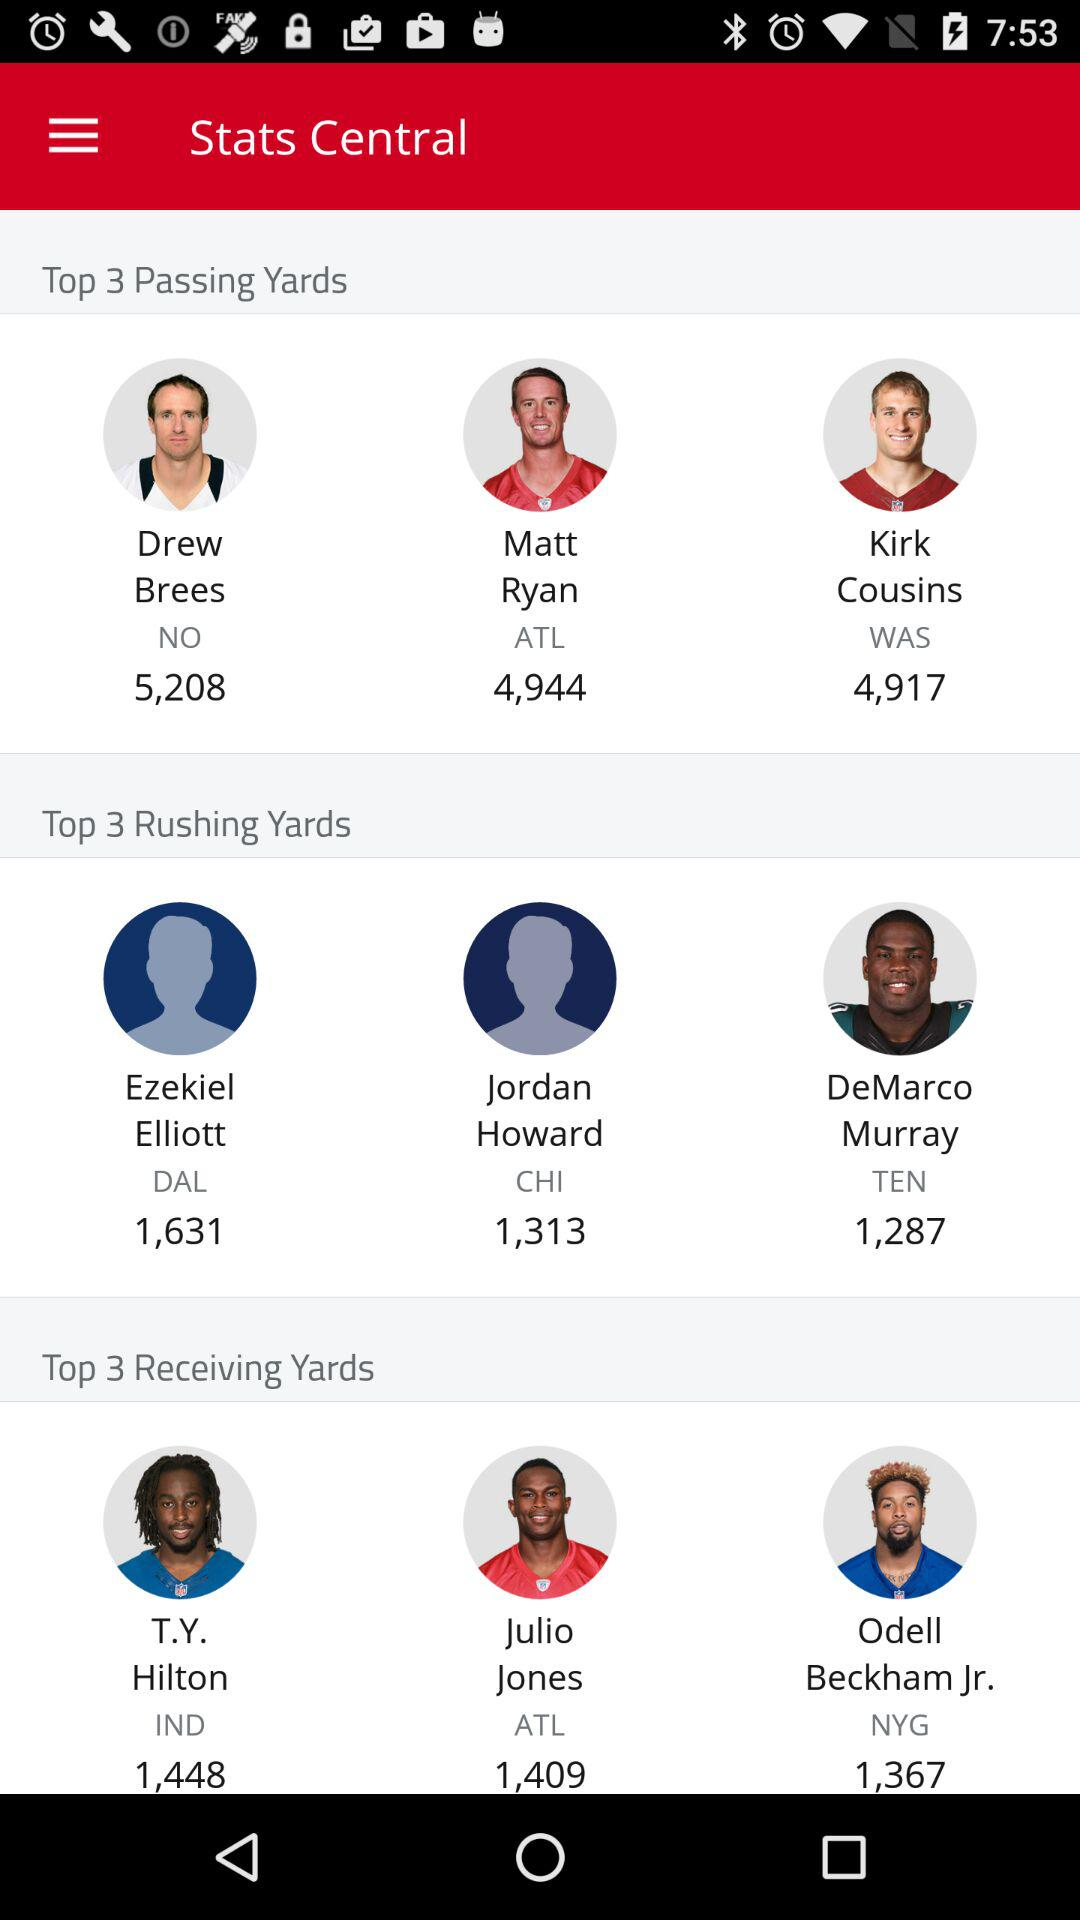Who are the top 3 rushing yards? The top 3 rushing yards are Ezekiel Elliott, Jordan Howard and DeMarco Murray. 